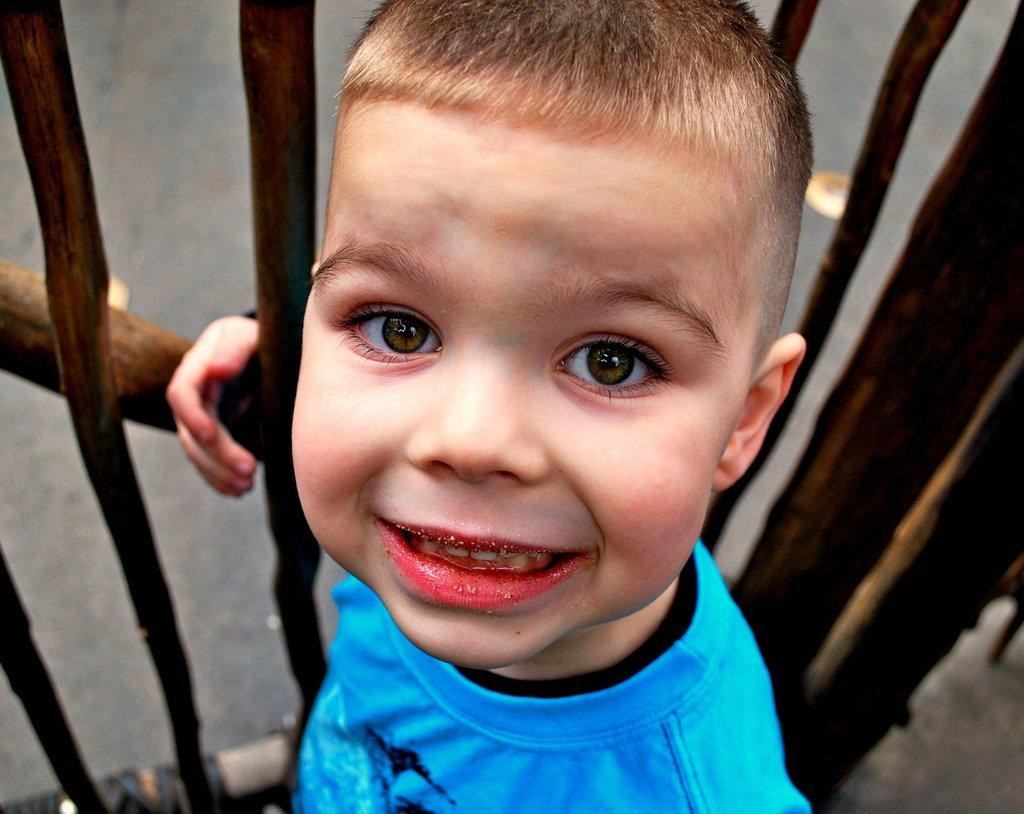Who is in the image? There is a boy in the image. What is the boy wearing? The boy is wearing a black and blue t-shirt. What expression does the boy have? The boy is smiling. What can be seen in the background of the image? There is wooden railing and the ground visible in the image. What type of throne is the boy sitting on in the image? There is no throne present in the image; the boy is standing. 